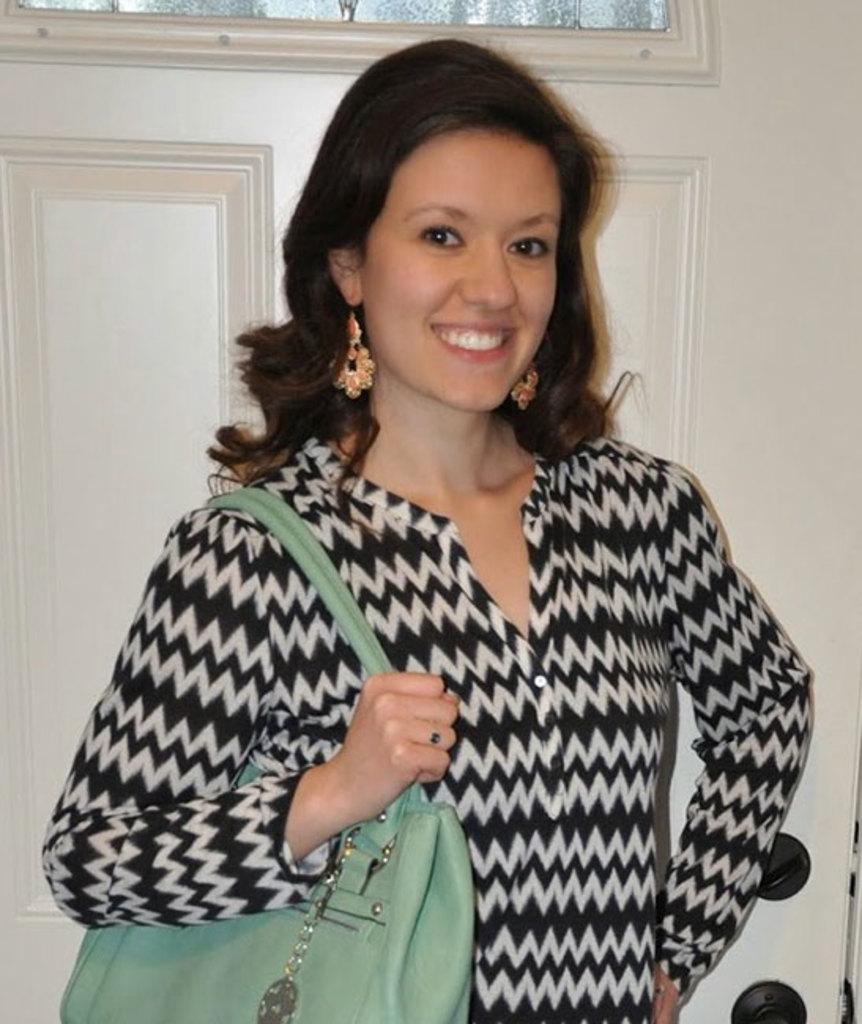Who is the main subject in the image? There is a woman in the image. What is the woman doing in the image? The woman is standing in front of a door. What is the woman's facial expression in the image? The woman is smiling. What accessory is the woman wearing in the image? The woman is wearing a green handbag. How many dogs are visible in the image? There are no dogs present in the image. What advice does the woman's mom give her in the image? There is no reference to the woman's mom or any advice in the image. What type of lipstick is the woman wearing in the image? There is no mention of lipstick or any makeup in the image. 